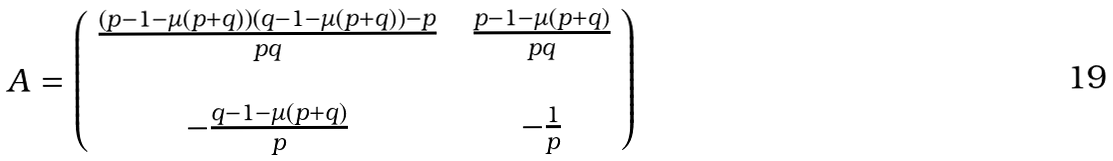Convert formula to latex. <formula><loc_0><loc_0><loc_500><loc_500>A = \left ( \begin{array} { c c c } \frac { \left ( p - 1 - \mu ( p + q ) \right ) \left ( q - 1 - \mu ( p + q ) \right ) - p } { p q } & & \frac { p - 1 - \mu ( p + q ) } { p q } \\ & & \\ - \frac { q - 1 - \mu ( p + q ) } { p } & & - \frac { 1 } { p } \end{array} \right )</formula> 